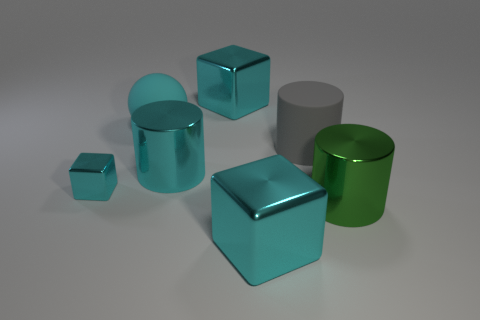What shape is the matte thing that is the same color as the tiny metallic object?
Ensure brevity in your answer.  Sphere. What number of things are either large cyan shiny objects or big gray matte cubes?
Offer a terse response. 3. There is a metal cube that is behind the tiny object; does it have the same size as the thing that is on the left side of the ball?
Your answer should be compact. No. What number of objects are large cyan metal objects that are behind the cyan sphere or big things behind the small cyan shiny block?
Provide a succinct answer. 4. Is the tiny object made of the same material as the cyan cube that is behind the tiny object?
Provide a short and direct response. Yes. What number of other objects are there of the same shape as the large green metal thing?
Provide a succinct answer. 2. There is a small cube on the left side of the metal cylinder that is on the left side of the cyan shiny cube that is behind the big cyan sphere; what is it made of?
Provide a short and direct response. Metal. Is the number of cyan metal things that are right of the large cyan sphere the same as the number of cyan balls?
Your answer should be compact. No. Is the tiny object to the left of the large cyan metal cylinder made of the same material as the big cyan sphere that is behind the large cyan cylinder?
Give a very brief answer. No. Does the cyan metal object that is on the left side of the big matte ball have the same shape as the large shiny thing right of the gray rubber cylinder?
Offer a terse response. No. 